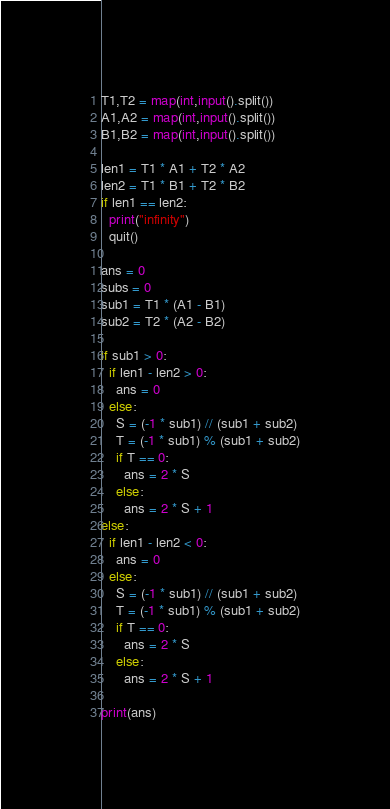<code> <loc_0><loc_0><loc_500><loc_500><_Python_>T1,T2 = map(int,input().split())
A1,A2 = map(int,input().split())
B1,B2 = map(int,input().split())

len1 = T1 * A1 + T2 * A2
len2 = T1 * B1 + T2 * B2
if len1 == len2:
  print("infinity")
  quit()

ans = 0
subs = 0  
sub1 = T1 * (A1 - B1)
sub2 = T2 * (A2 - B2)

if sub1 > 0:
  if len1 - len2 > 0:
    ans = 0
  else:
    S = (-1 * sub1) // (sub1 + sub2)
    T = (-1 * sub1) % (sub1 + sub2)
    if T == 0:
      ans = 2 * S
    else:
      ans = 2 * S + 1
else:
  if len1 - len2 < 0:
    ans = 0
  else:
    S = (-1 * sub1) // (sub1 + sub2)
    T = (-1 * sub1) % (sub1 + sub2)
    if T == 0:
      ans = 2 * S
    else:
      ans = 2 * S + 1
    
print(ans) </code> 